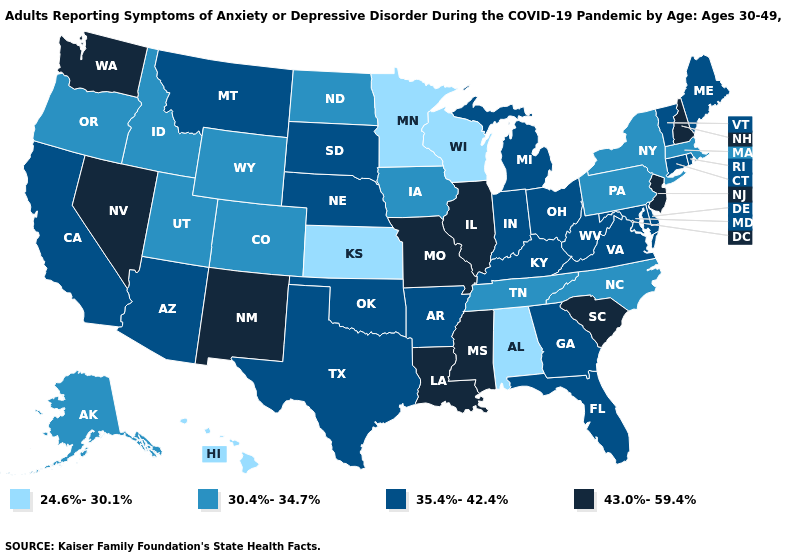What is the value of Nebraska?
Concise answer only. 35.4%-42.4%. What is the lowest value in the USA?
Give a very brief answer. 24.6%-30.1%. Name the states that have a value in the range 43.0%-59.4%?
Give a very brief answer. Illinois, Louisiana, Mississippi, Missouri, Nevada, New Hampshire, New Jersey, New Mexico, South Carolina, Washington. Does California have the same value as Delaware?
Short answer required. Yes. What is the value of Washington?
Keep it brief. 43.0%-59.4%. Does Wisconsin have the same value as Hawaii?
Keep it brief. Yes. Does Mississippi have the highest value in the USA?
Keep it brief. Yes. What is the value of Minnesota?
Be succinct. 24.6%-30.1%. What is the value of Maryland?
Be succinct. 35.4%-42.4%. Is the legend a continuous bar?
Give a very brief answer. No. Which states hav the highest value in the MidWest?
Short answer required. Illinois, Missouri. Among the states that border Minnesota , which have the lowest value?
Write a very short answer. Wisconsin. Name the states that have a value in the range 24.6%-30.1%?
Concise answer only. Alabama, Hawaii, Kansas, Minnesota, Wisconsin. Is the legend a continuous bar?
Write a very short answer. No. Does the map have missing data?
Keep it brief. No. 